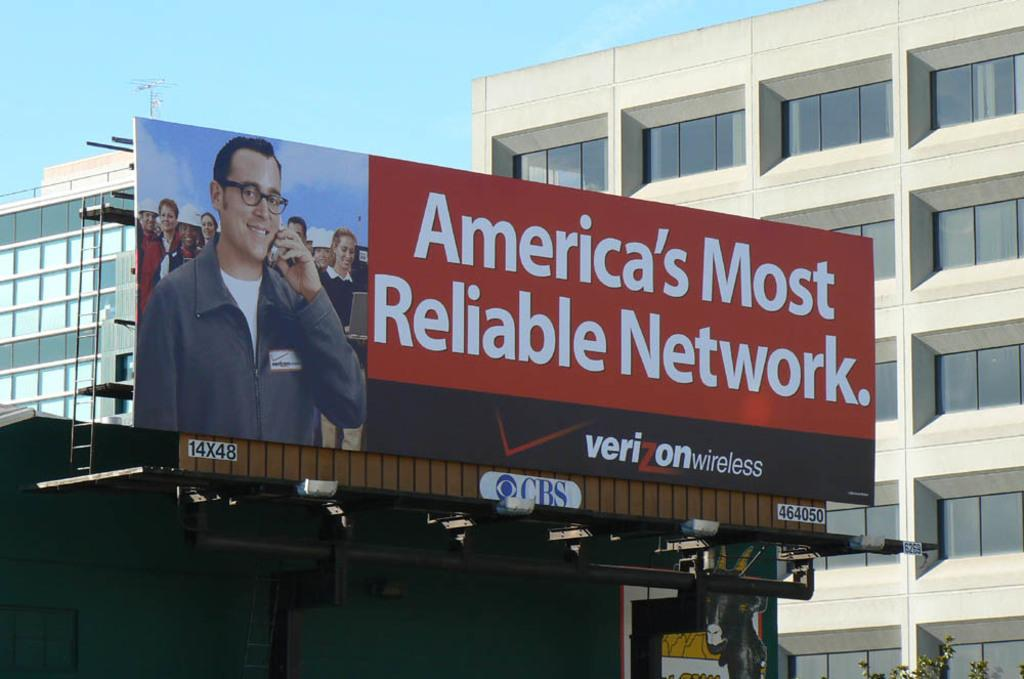<image>
Share a concise interpretation of the image provided. A Verizon wireless billboard has a man holding a phone to his ear. 